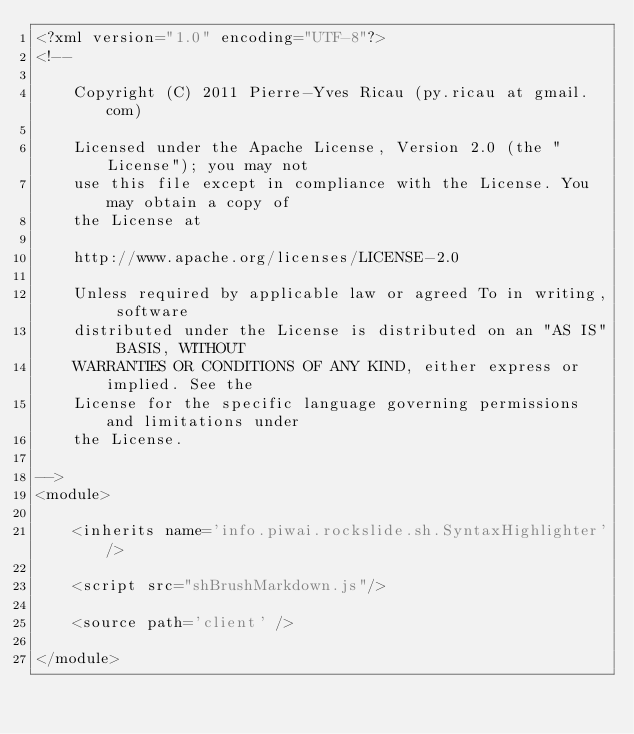Convert code to text. <code><loc_0><loc_0><loc_500><loc_500><_XML_><?xml version="1.0" encoding="UTF-8"?>
<!--

    Copyright (C) 2011 Pierre-Yves Ricau (py.ricau at gmail.com)

    Licensed under the Apache License, Version 2.0 (the "License"); you may not
    use this file except in compliance with the License. You may obtain a copy of
    the License at

    http://www.apache.org/licenses/LICENSE-2.0

    Unless required by applicable law or agreed To in writing, software
    distributed under the License is distributed on an "AS IS" BASIS, WITHOUT
    WARRANTIES OR CONDITIONS OF ANY KIND, either express or implied. See the
    License for the specific language governing permissions and limitations under
    the License.

-->
<module>

    <inherits name='info.piwai.rockslide.sh.SyntaxHighlighter'/>

	<script src="shBrushMarkdown.js"/>
  
    <source path='client' />

</module>
</code> 